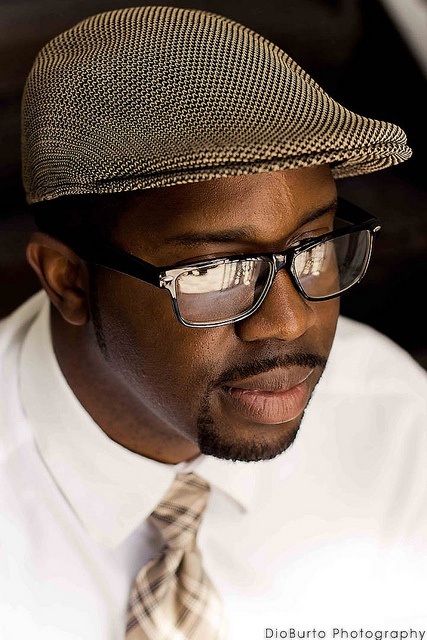Describe the objects in this image and their specific colors. I can see people in white, black, maroon, and gray tones and tie in black, tan, and ivory tones in this image. 